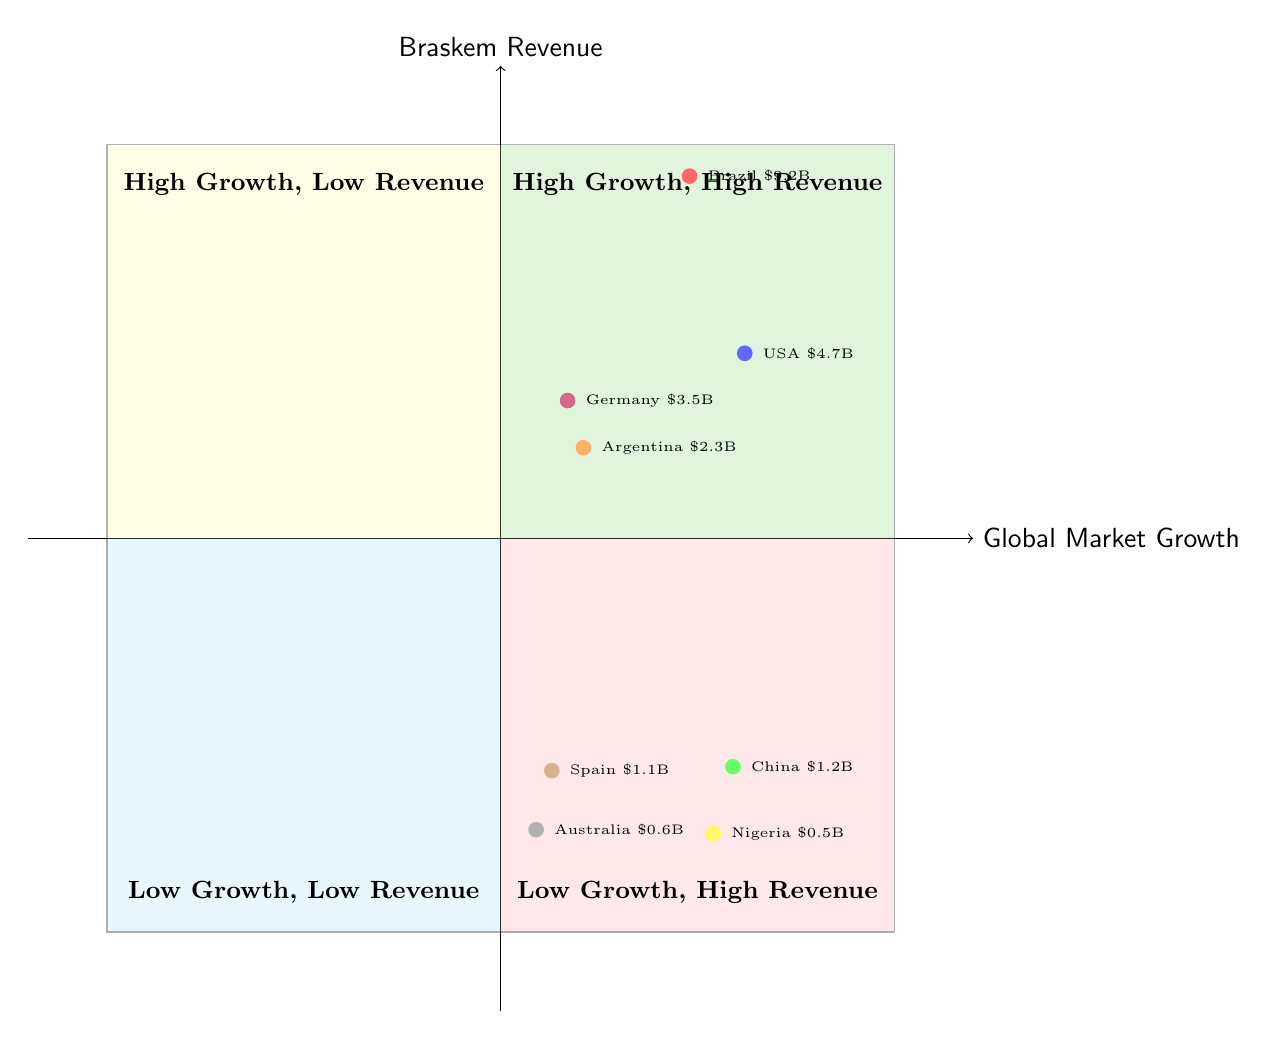What is the Braskem revenue from Brazil? Brazil is located in the "High Growth, High Revenue" quadrant, which shows a Braskem revenue of $9.2 Billion.
Answer: $9.2 Billion Which region has the lowest Braskem revenue? The region with the lowest Braskem revenue is Australia, located in the "Low Growth, Low Revenue" quadrant, with a revenue of $0.6 Billion.
Answer: $0.6 Billion How many regions are in the "High Growth, Low Revenue" quadrant? There are two regions in the "High Growth, Low Revenue" quadrant: China and Nigeria.
Answer: 2 What is the global market growth percentage for Germany? Germany is represented in the "Low Growth, High Revenue" quadrant with a global market growth of 1.7%.
Answer: 1.7% Which quadrant contains the USA? The USA is in the "High Growth, High Revenue" quadrant, with a global market growth of 6.2% and Braskem revenue of $4.7 Billion.
Answer: High Growth, High Revenue Which region shows both low growth and low revenue? Australia shows low growth and low revenue at 0.9% growth and $0.6 Billion revenue, located in the "Low Growth, Low Revenue" quadrant.
Answer: Australia Which quadrant has the highest global market growth percentages? The "High Growth, High Revenue" quadrant displays the highest global market growth percentages, including Brazil at 4.8% and the USA at 6.2%.
Answer: High Growth, High Revenue What is the combined revenue of regions in the "Low Growth, High Revenue" quadrant? The combined revenue for Germany and Argentina in the "Low Growth, High Revenue" quadrant is $3.5 Billion + $2.3 Billion = $5.8 Billion.
Answer: $5.8 Billion Which country in the "High Growth, Low Revenue" quadrant has the highest revenue? In the "High Growth, Low Revenue" quadrant, China has the highest revenue at $1.2 Billion compared to Nigeria's $0.5 Billion.
Answer: China 